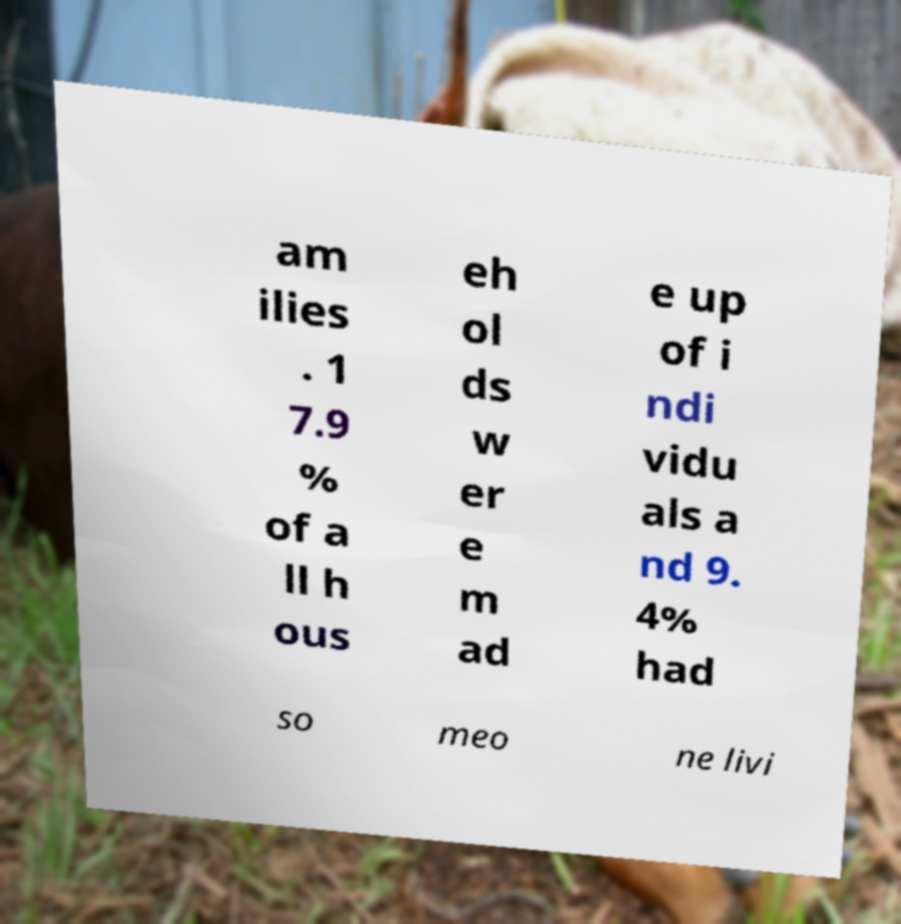Please read and relay the text visible in this image. What does it say? am ilies . 1 7.9 % of a ll h ous eh ol ds w er e m ad e up of i ndi vidu als a nd 9. 4% had so meo ne livi 